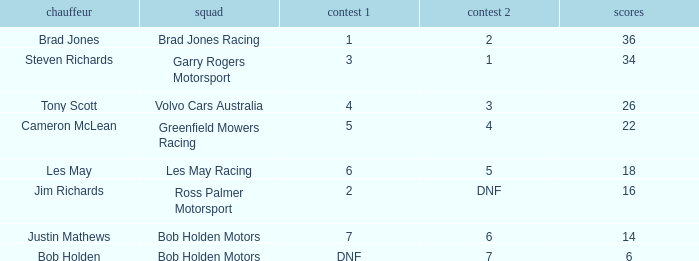Which team received 4 in race 1? Volvo Cars Australia. 